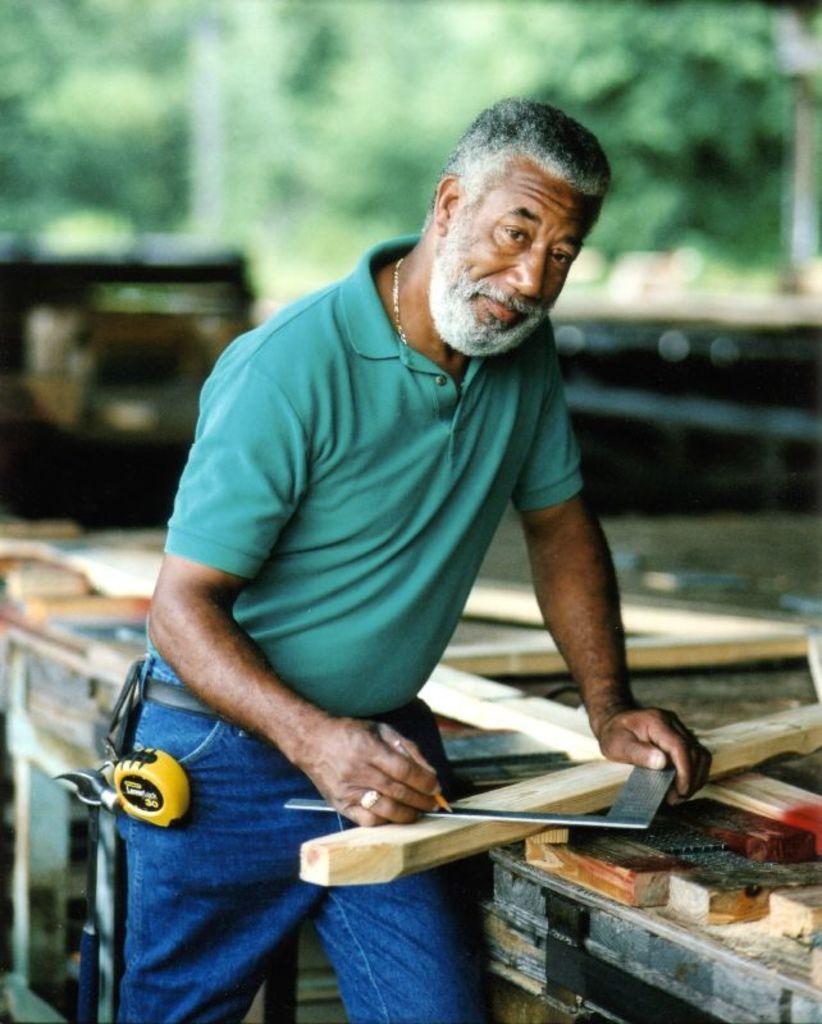Could you give a brief overview of what you see in this image? In this image we can see a carpenter, the person is holding a pencil and making marks on a piece of wood. 